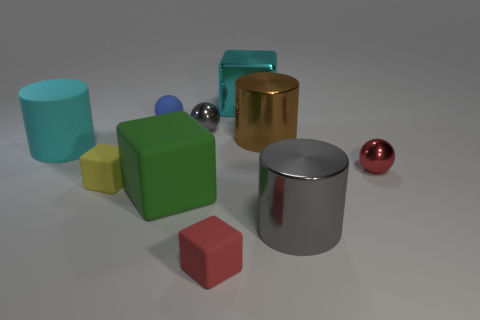Subtract 1 cylinders. How many cylinders are left? 2 Subtract all small red matte cubes. How many cubes are left? 3 Subtract all brown cubes. Subtract all green cylinders. How many cubes are left? 4 Subtract all cubes. How many objects are left? 6 Subtract 0 blue blocks. How many objects are left? 10 Subtract all big cyan cylinders. Subtract all big green blocks. How many objects are left? 8 Add 8 large cyan matte objects. How many large cyan matte objects are left? 9 Add 1 big green objects. How many big green objects exist? 2 